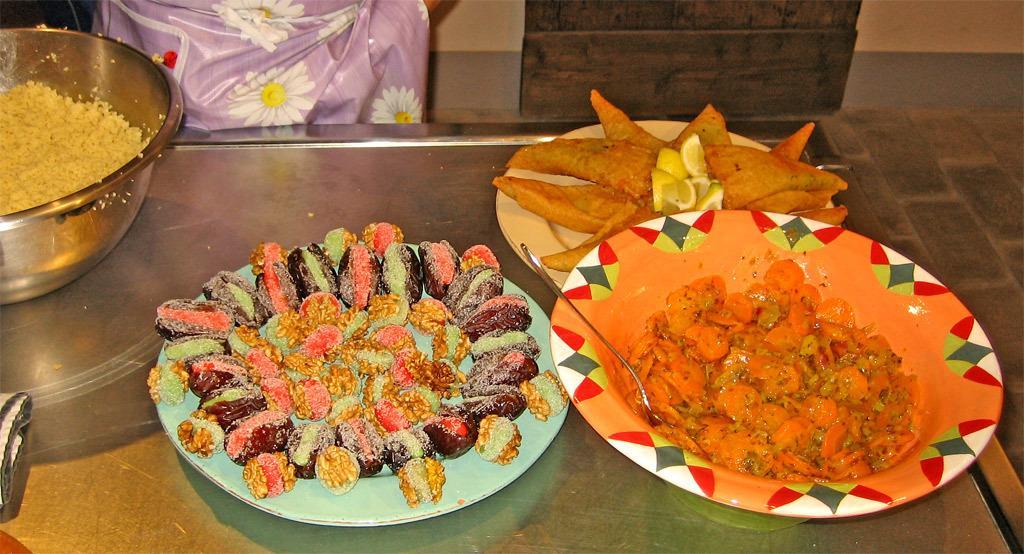Please provide a concise description of this image. In this picture we can see there are three plates and a bowl on an object. On the plates and in a bowl there are some food items and a spoon. Behind the object there is a wall. 